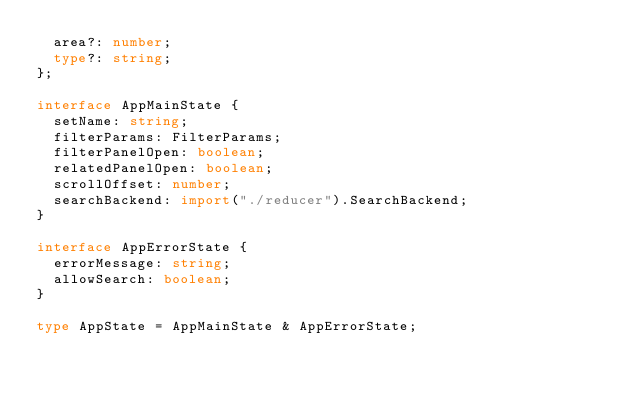<code> <loc_0><loc_0><loc_500><loc_500><_TypeScript_>  area?: number;
  type?: string;
};

interface AppMainState {
  setName: string;
  filterParams: FilterParams;
  filterPanelOpen: boolean;
  relatedPanelOpen: boolean;
  scrollOffset: number;
  searchBackend: import("./reducer").SearchBackend;
}

interface AppErrorState {
  errorMessage: string;
  allowSearch: boolean;
}

type AppState = AppMainState & AppErrorState;
</code> 